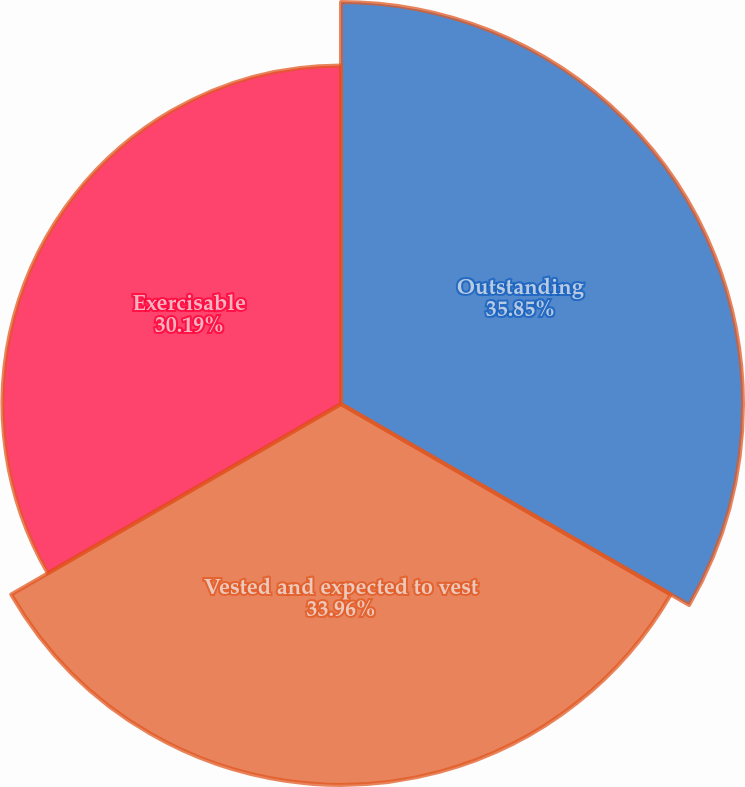<chart> <loc_0><loc_0><loc_500><loc_500><pie_chart><fcel>Outstanding<fcel>Vested and expected to vest<fcel>Exercisable<nl><fcel>35.85%<fcel>33.96%<fcel>30.19%<nl></chart> 